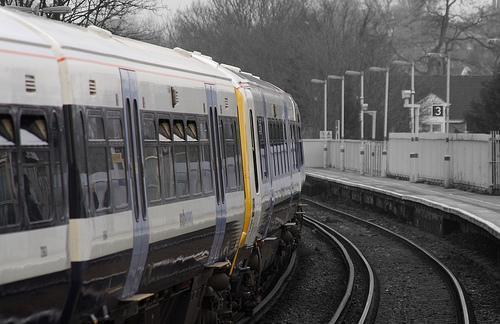How many trains in the train tracks?
Give a very brief answer. 1. 